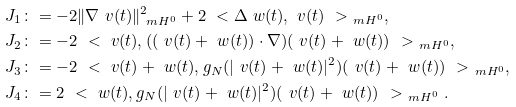Convert formula to latex. <formula><loc_0><loc_0><loc_500><loc_500>J _ { 1 } & \colon = - 2 \| \nabla \ v ( t ) \| ^ { 2 } _ { \ m H ^ { 0 } } + 2 \ < \Delta \ w ( t ) , \ v ( t ) \ > _ { \ m H ^ { 0 } } , \\ J _ { 2 } & \colon = - 2 \ < \ v ( t ) , ( ( \ v ( t ) + \ w ( t ) ) \cdot \nabla ) ( \ v ( t ) + \ w ( t ) ) \ > _ { \ m H ^ { 0 } } , \\ J _ { 3 } & \colon = - 2 \ < \ v ( t ) + \ w ( t ) , g _ { N } ( | \ v ( t ) + \ w ( t ) | ^ { 2 } ) ( \ v ( t ) + \ w ( t ) ) \ > _ { \ m H ^ { 0 } } , \\ J _ { 4 } & \colon = 2 \ < \ w ( t ) , g _ { N } ( | \ v ( t ) + \ w ( t ) | ^ { 2 } ) ( \ v ( t ) + \ w ( t ) ) \ > _ { \ m H ^ { 0 } } .</formula> 